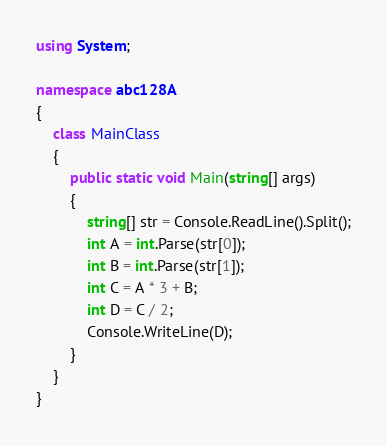<code> <loc_0><loc_0><loc_500><loc_500><_C#_>using System;

namespace abc128A
{
    class MainClass
    {
        public static void Main(string[] args)
        {
            string[] str = Console.ReadLine().Split();
            int A = int.Parse(str[0]);
            int B = int.Parse(str[1]);
            int C = A * 3 + B;
            int D = C / 2;
            Console.WriteLine(D);
        }
    }
}
</code> 